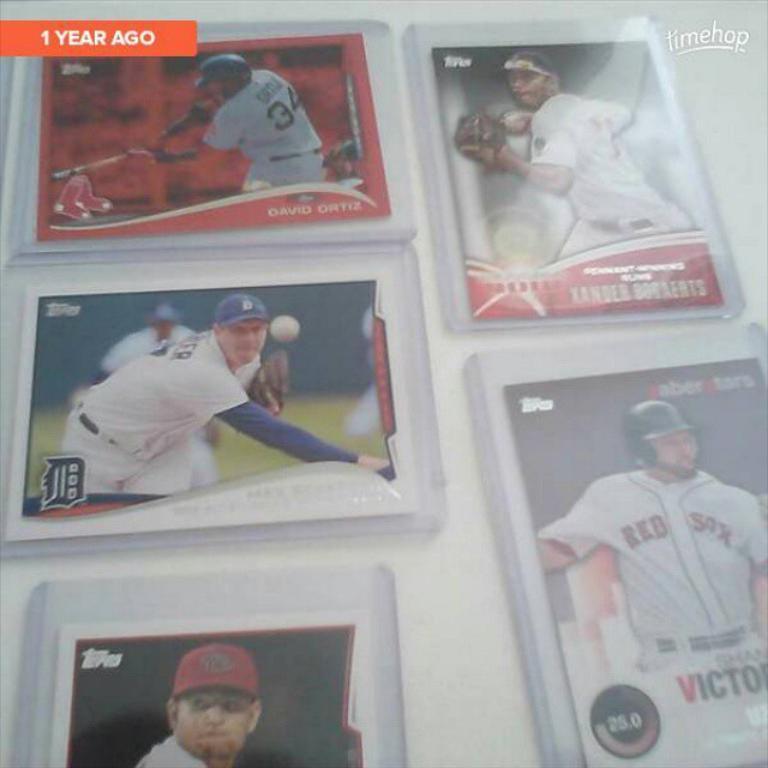Can you describe this image briefly? In this image we can see photos of persons to the wall. 